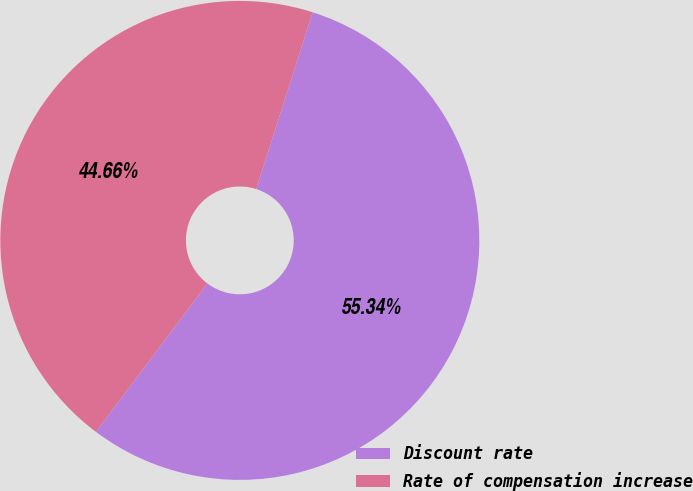<chart> <loc_0><loc_0><loc_500><loc_500><pie_chart><fcel>Discount rate<fcel>Rate of compensation increase<nl><fcel>55.34%<fcel>44.66%<nl></chart> 